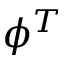Convert formula to latex. <formula><loc_0><loc_0><loc_500><loc_500>\phi ^ { T }</formula> 